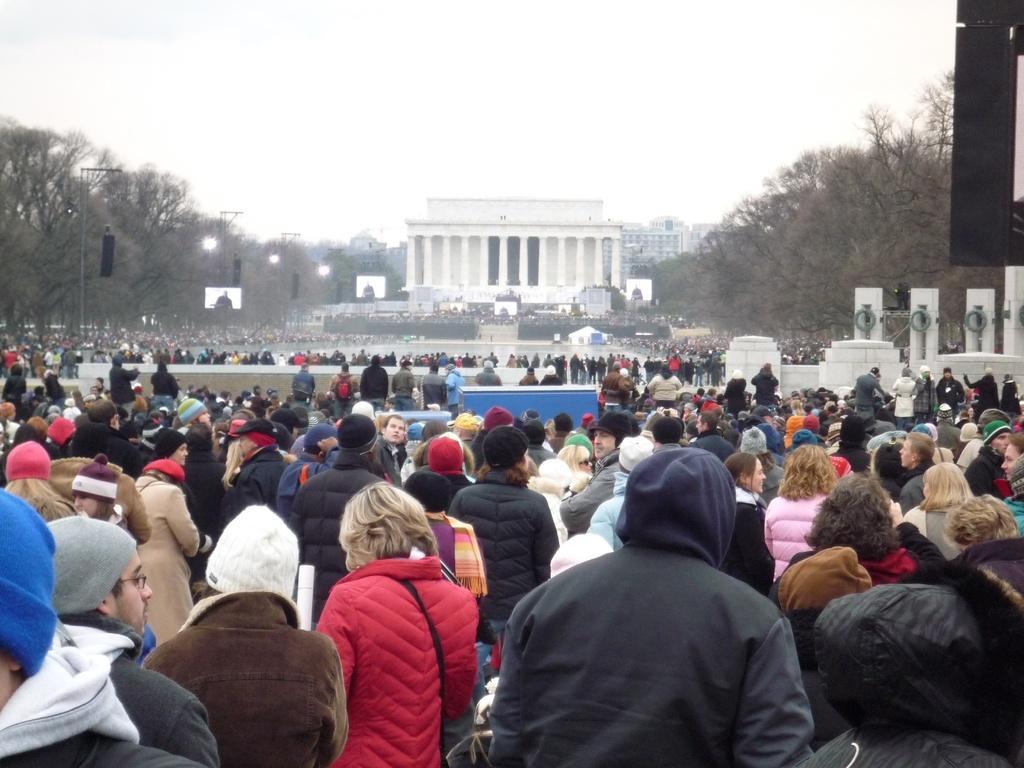Can you describe this image briefly? In this image I can see a group of people and wearing different color dresses. I can see few buildings,trees,light poles,boards and white color statues. The sky is in white color. 